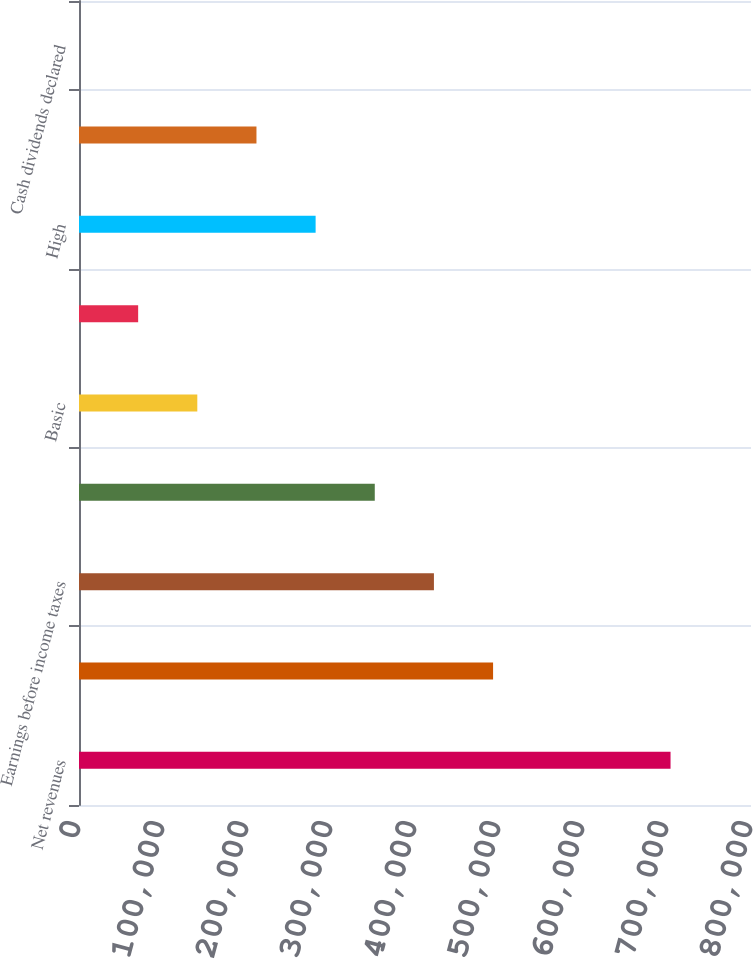Convert chart to OTSL. <chart><loc_0><loc_0><loc_500><loc_500><bar_chart><fcel>Net revenues<fcel>Gross profit<fcel>Earnings before income taxes<fcel>Net earnings<fcel>Basic<fcel>Diluted<fcel>High<fcel>Low<fcel>Cash dividends declared<nl><fcel>704220<fcel>492954<fcel>422532<fcel>352110<fcel>140844<fcel>70422.2<fcel>281688<fcel>211266<fcel>0.2<nl></chart> 